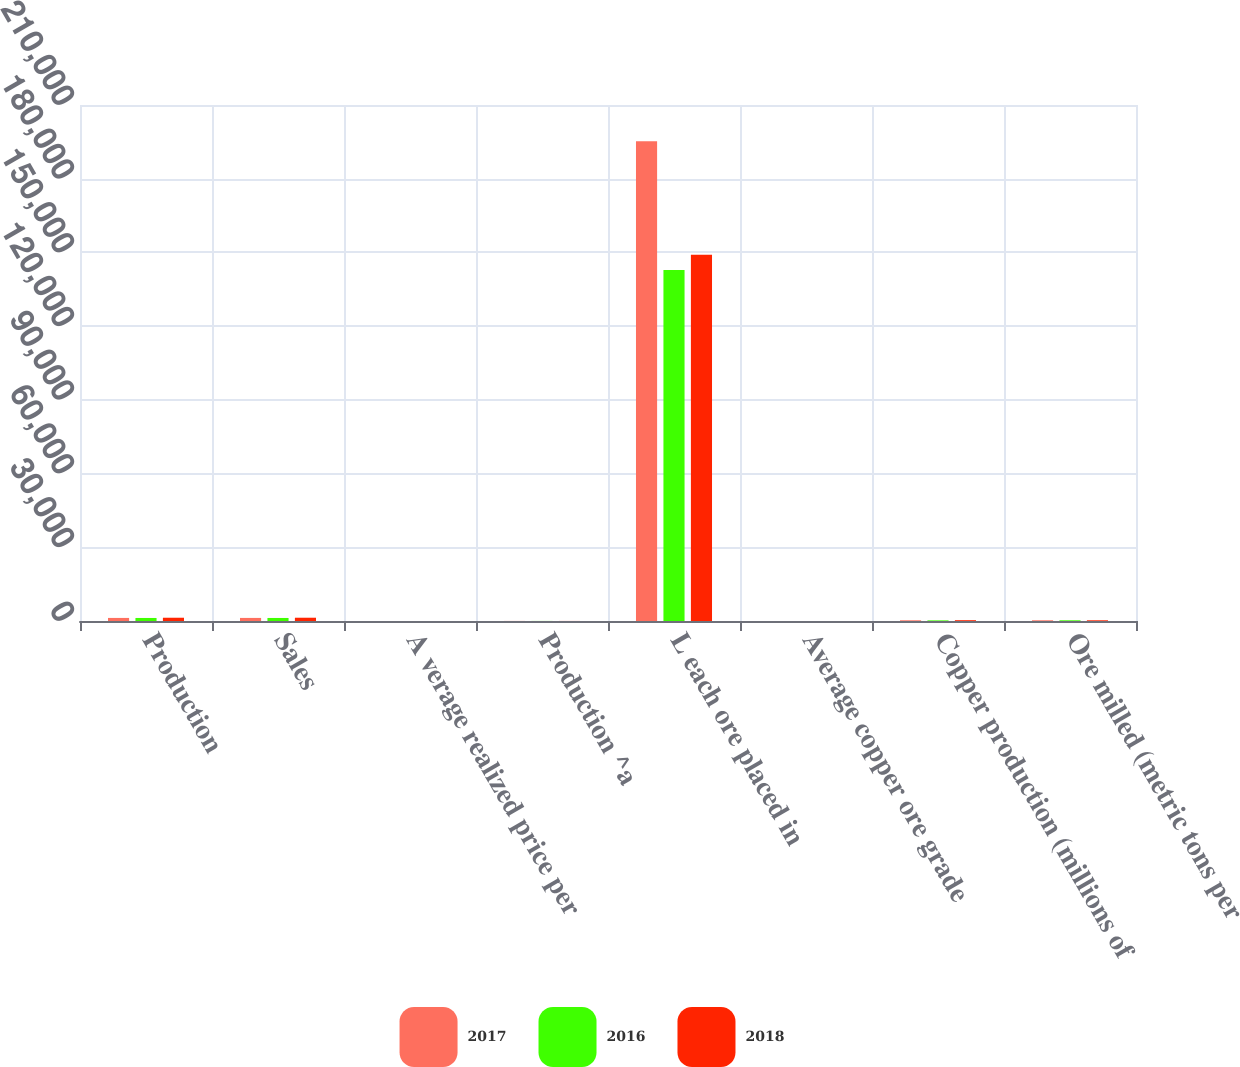Convert chart. <chart><loc_0><loc_0><loc_500><loc_500><stacked_bar_chart><ecel><fcel>Production<fcel>Sales<fcel>A verage realized price per<fcel>Production ^a<fcel>L each ore placed in<fcel>Average copper ore grade<fcel>Copper production (millions of<fcel>Ore milled (metric tons per<nl><fcel>2017<fcel>1249<fcel>1253<fcel>2.87<fcel>28<fcel>195200<fcel>0.33<fcel>287<fcel>287<nl><fcel>2016<fcel>1235<fcel>1235<fcel>2.97<fcel>27<fcel>142800<fcel>0.37<fcel>255<fcel>287<nl><fcel>2018<fcel>1328<fcel>1332<fcel>2.31<fcel>21<fcel>149100<fcel>0.41<fcel>328<fcel>287<nl></chart> 